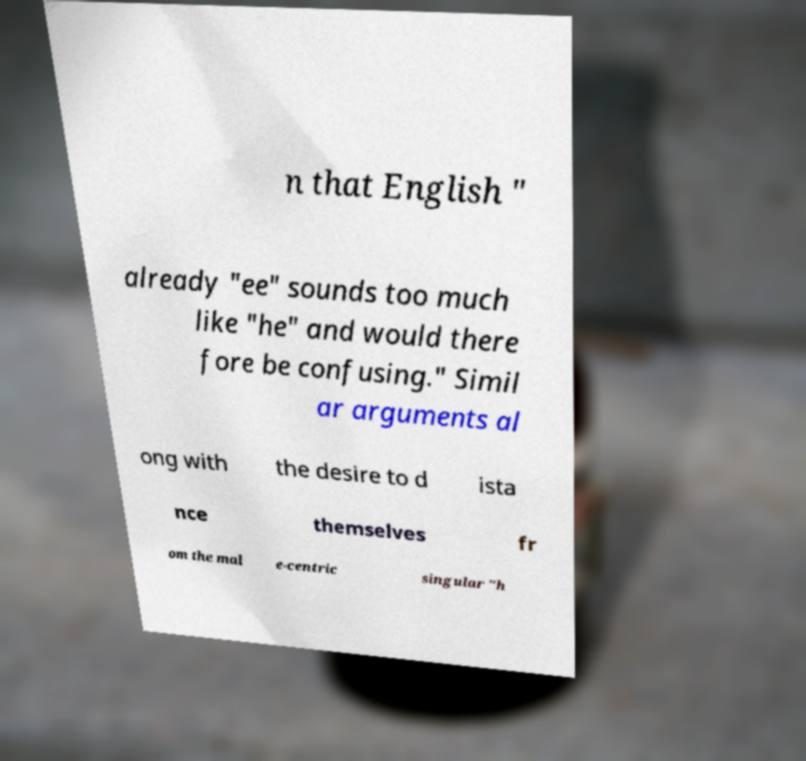Please read and relay the text visible in this image. What does it say? n that English " already "ee" sounds too much like "he" and would there fore be confusing." Simil ar arguments al ong with the desire to d ista nce themselves fr om the mal e-centric singular "h 